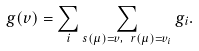Convert formula to latex. <formula><loc_0><loc_0><loc_500><loc_500>g ( v ) = \sum _ { i } \sum _ { s ( \mu ) = v , \ r ( \mu ) = v _ { i } } g _ { i } .</formula> 